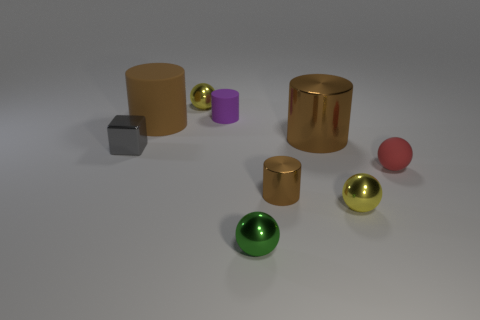Subtract all gray spheres. How many brown cylinders are left? 3 Add 1 tiny shiny balls. How many objects exist? 10 Subtract all cylinders. How many objects are left? 5 Add 1 purple spheres. How many purple spheres exist? 1 Subtract 1 green balls. How many objects are left? 8 Subtract all red rubber spheres. Subtract all brown rubber cylinders. How many objects are left? 7 Add 1 tiny blocks. How many tiny blocks are left? 2 